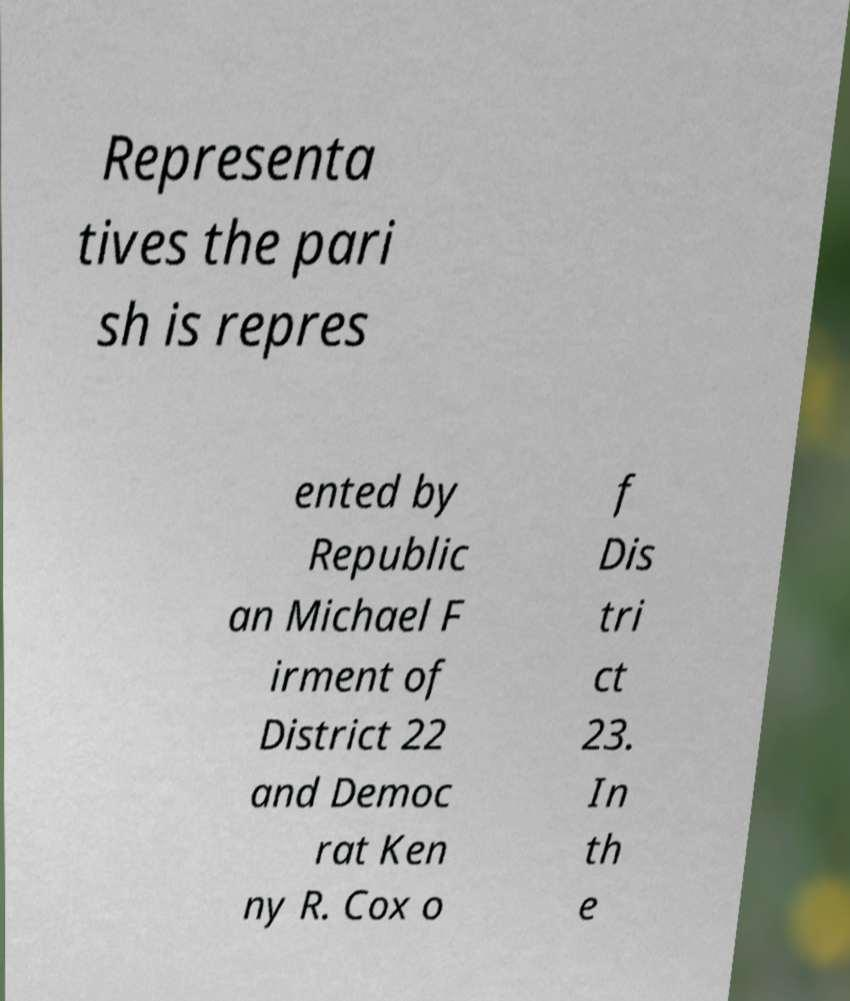Please read and relay the text visible in this image. What does it say? Representa tives the pari sh is repres ented by Republic an Michael F irment of District 22 and Democ rat Ken ny R. Cox o f Dis tri ct 23. In th e 